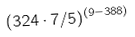Convert formula to latex. <formula><loc_0><loc_0><loc_500><loc_500>( 3 2 4 \cdot 7 / 5 ) ^ { ( 9 - 3 8 8 ) }</formula> 